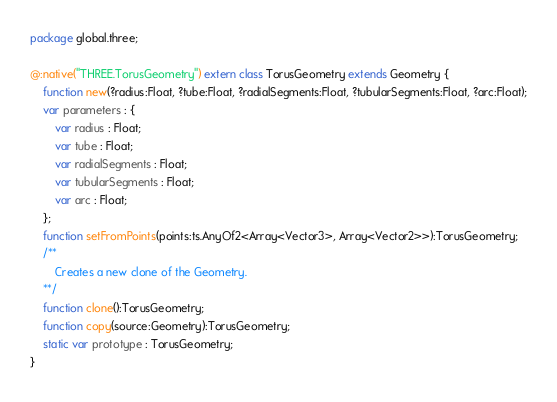Convert code to text. <code><loc_0><loc_0><loc_500><loc_500><_Haxe_>package global.three;

@:native("THREE.TorusGeometry") extern class TorusGeometry extends Geometry {
	function new(?radius:Float, ?tube:Float, ?radialSegments:Float, ?tubularSegments:Float, ?arc:Float);
	var parameters : {
		var radius : Float;
		var tube : Float;
		var radialSegments : Float;
		var tubularSegments : Float;
		var arc : Float;
	};
	function setFromPoints(points:ts.AnyOf2<Array<Vector3>, Array<Vector2>>):TorusGeometry;
	/**
		Creates a new clone of the Geometry.
	**/
	function clone():TorusGeometry;
	function copy(source:Geometry):TorusGeometry;
	static var prototype : TorusGeometry;
}</code> 